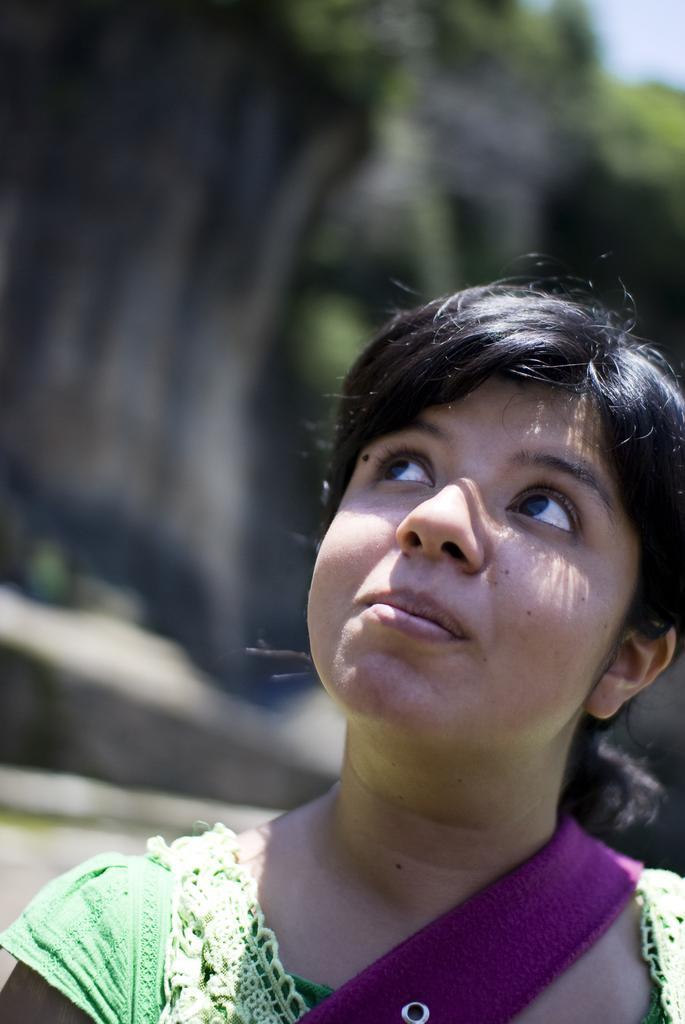Describe this image in one or two sentences. This image consists of a woman wearing a green dress. In the background, there are trees. And the background is blurred. 